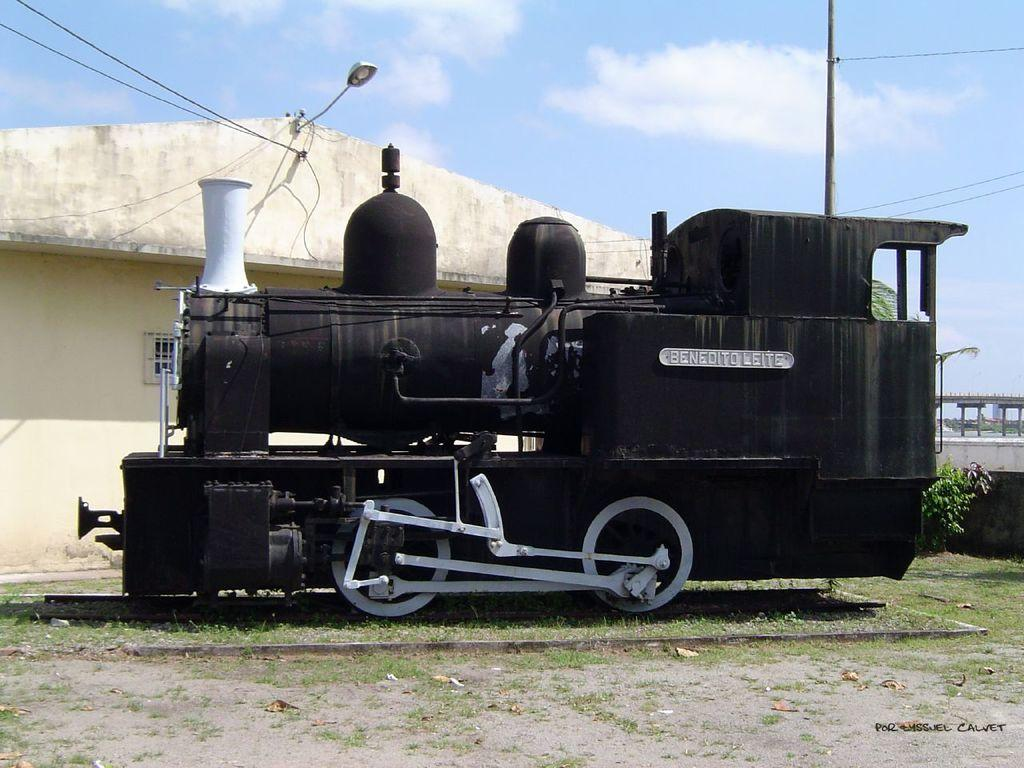What is the main subject of the image? There is a train in the image. Where is the train located? The train is in the middle of a grassland. What can be seen behind the train? There is a building behind the train. What is visible in the sky in the image? The sky is visible in the image, and clouds are present. What type of jam is being spread on the bread in the image? There is no bread or jam present in the image; it features a train in a grassland with a building in the background and clouds in the sky. 